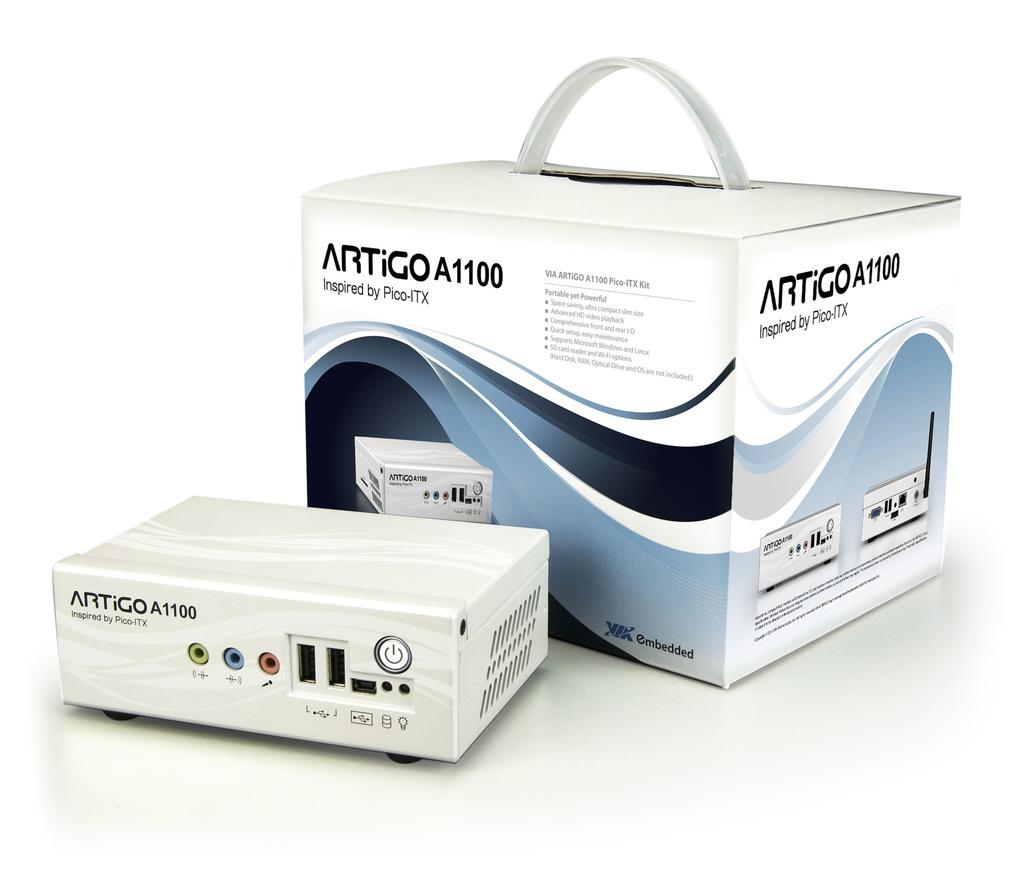<image>
Relay a brief, clear account of the picture shown. A white Artigo A1100 sits in front of its box. 